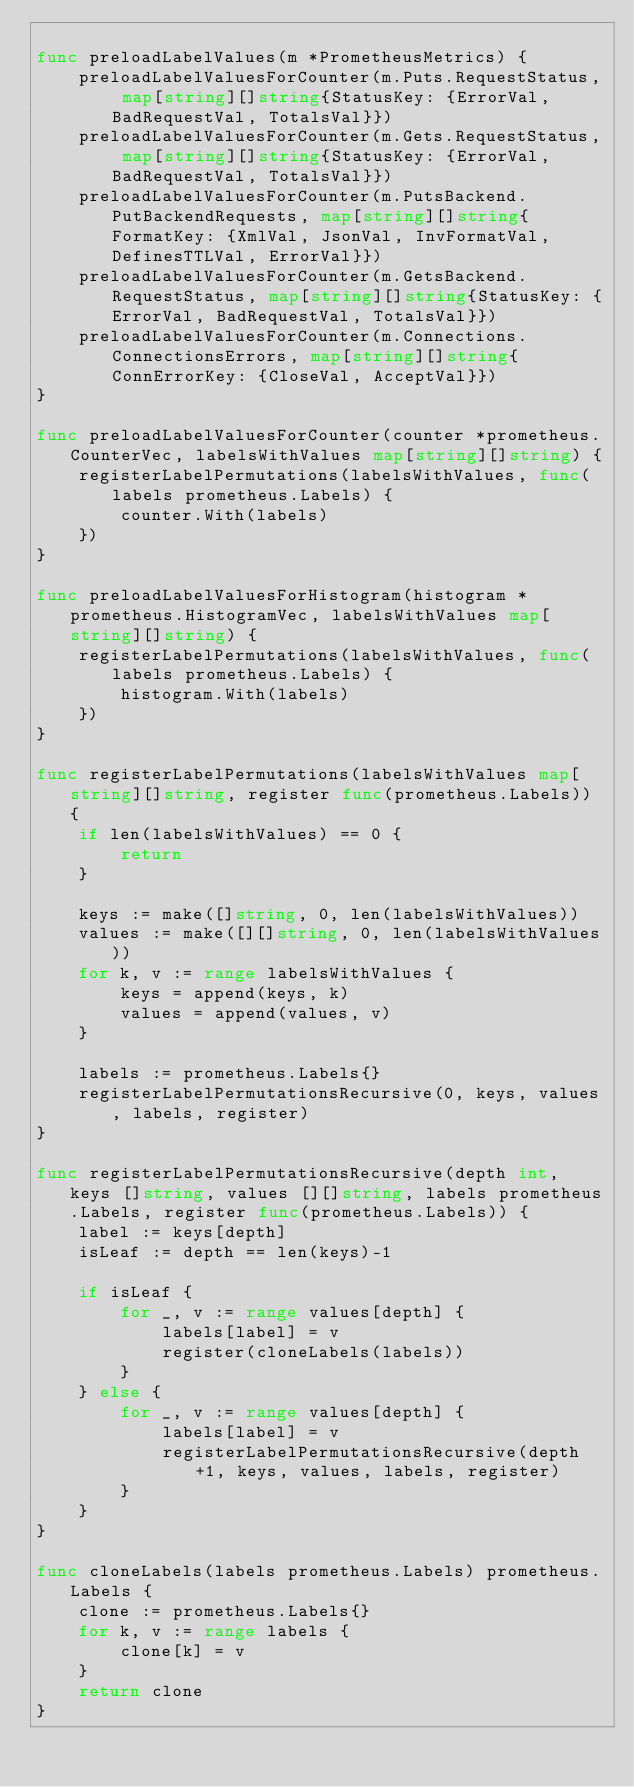Convert code to text. <code><loc_0><loc_0><loc_500><loc_500><_Go_>
func preloadLabelValues(m *PrometheusMetrics) {
	preloadLabelValuesForCounter(m.Puts.RequestStatus, map[string][]string{StatusKey: {ErrorVal, BadRequestVal, TotalsVal}})
	preloadLabelValuesForCounter(m.Gets.RequestStatus, map[string][]string{StatusKey: {ErrorVal, BadRequestVal, TotalsVal}})
	preloadLabelValuesForCounter(m.PutsBackend.PutBackendRequests, map[string][]string{FormatKey: {XmlVal, JsonVal, InvFormatVal, DefinesTTLVal, ErrorVal}})
	preloadLabelValuesForCounter(m.GetsBackend.RequestStatus, map[string][]string{StatusKey: {ErrorVal, BadRequestVal, TotalsVal}})
	preloadLabelValuesForCounter(m.Connections.ConnectionsErrors, map[string][]string{ConnErrorKey: {CloseVal, AcceptVal}})
}

func preloadLabelValuesForCounter(counter *prometheus.CounterVec, labelsWithValues map[string][]string) {
	registerLabelPermutations(labelsWithValues, func(labels prometheus.Labels) {
		counter.With(labels)
	})
}

func preloadLabelValuesForHistogram(histogram *prometheus.HistogramVec, labelsWithValues map[string][]string) {
	registerLabelPermutations(labelsWithValues, func(labels prometheus.Labels) {
		histogram.With(labels)
	})
}

func registerLabelPermutations(labelsWithValues map[string][]string, register func(prometheus.Labels)) {
	if len(labelsWithValues) == 0 {
		return
	}

	keys := make([]string, 0, len(labelsWithValues))
	values := make([][]string, 0, len(labelsWithValues))
	for k, v := range labelsWithValues {
		keys = append(keys, k)
		values = append(values, v)
	}

	labels := prometheus.Labels{}
	registerLabelPermutationsRecursive(0, keys, values, labels, register)
}

func registerLabelPermutationsRecursive(depth int, keys []string, values [][]string, labels prometheus.Labels, register func(prometheus.Labels)) {
	label := keys[depth]
	isLeaf := depth == len(keys)-1

	if isLeaf {
		for _, v := range values[depth] {
			labels[label] = v
			register(cloneLabels(labels))
		}
	} else {
		for _, v := range values[depth] {
			labels[label] = v
			registerLabelPermutationsRecursive(depth+1, keys, values, labels, register)
		}
	}
}

func cloneLabels(labels prometheus.Labels) prometheus.Labels {
	clone := prometheus.Labels{}
	for k, v := range labels {
		clone[k] = v
	}
	return clone
}
</code> 